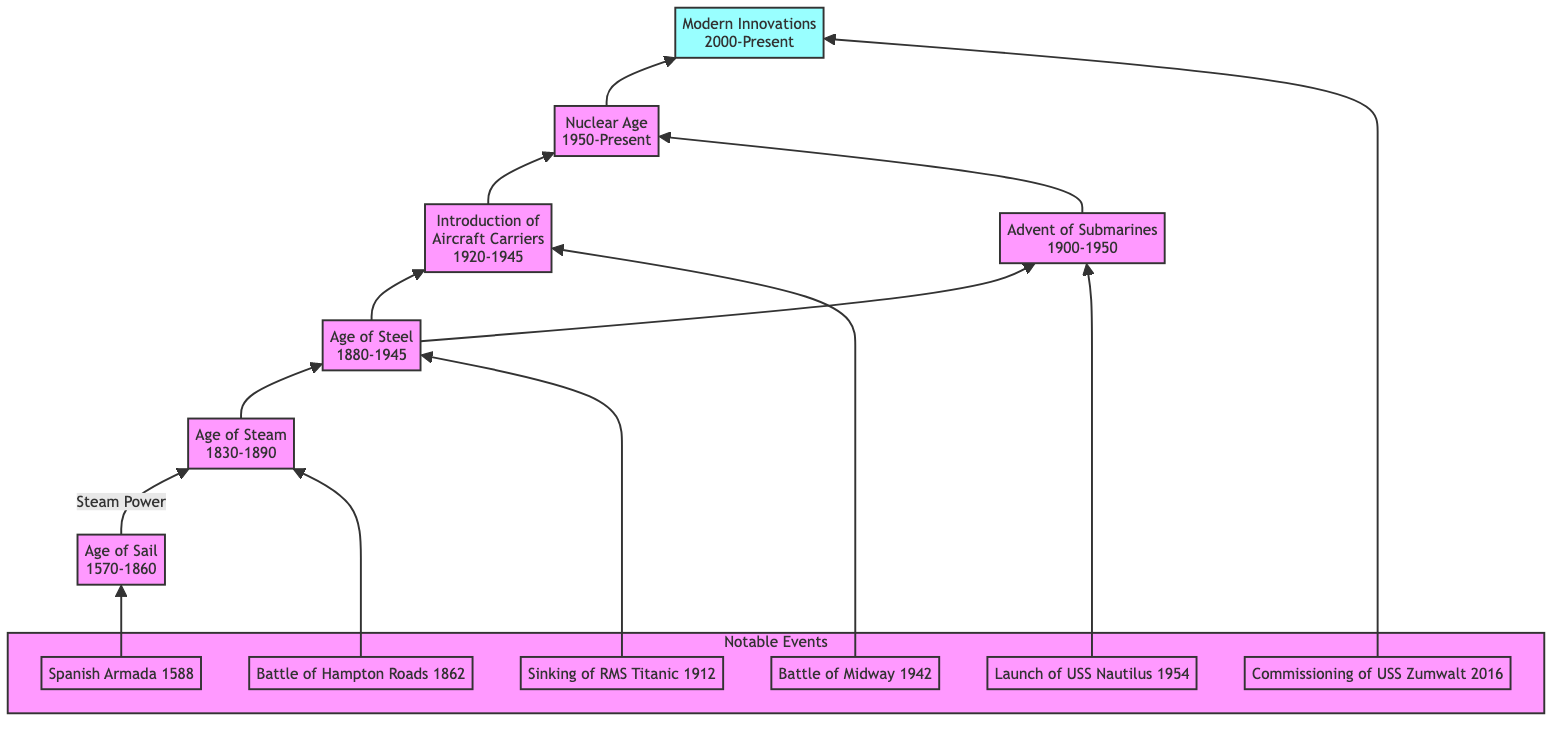What era introduced steam power in shipbuilding? The diagram shows that the Age of Steam (1830-1890) follows the Age of Sail (1570-1860) and is specifically marked by the introduction of steam power.
Answer: Age of Steam Which significant event corresponds to the Age of Steel? The diagram connects notable events to their respective eras. The sinking of the RMS Titanic in 1912 is linked to the Age of Steel (1880-1945).
Answer: Sinking of RMS Titanic Name a notable event associated with the introduction of aircraft carriers. The diagram lists notable events beneath the Introduction of Aircraft Carriers (1920-1945) node, specifically noting the Battle of Midway in 1942.
Answer: Battle of Midway How many major age categories are present in this shipbuilding progression? By counting the labeled age categories in the diagram—Age of Sail, Age of Steam, Age of Steel, Introduction of Aircraft Carriers, Advent of Submarines, Nuclear Age, and Modern Innovations—we find there are seven.
Answer: Seven Which ship type was introduced in the Nuclear Age? Looking at the Nuclear Age (1950-Present) in the diagram, it indicates the advancement to nuclear-powered ships, highlighting the USS Enterprise as a notable example.
Answer: Nuclear-powered ships Which two ages lead directly to the nuclear age? The diagram illustrates connections from the Age of Steel and the Advent of Submarines leading to the Nuclear Age, indicating they are both predecessors of this era.
Answer: Age of Steel and Advent of Submarines What is the latest innovation marked in the modern innovations era? The modern innovations era includes advancements such as the commissioning of the USS Zumwalt in 2016, which is indicated as a notable event in that section of the diagram.
Answer: Commissioning of USS Zumwalt How many edges connect the Age of Steel to subsequent naval developments? Within the diagram, the Age of Steel connects to three subsequent developments: Introduction of Aircraft Carriers, Advent of Submarines, and the Nuclear Age, creating three outgoing edges from that node.
Answer: Three What denotes the transition from wooden ships to nuclear submarines? The progression displayed in the diagram, which moves from the Age of Sail, through various ages, ultimately leading to the Nuclear Age and modern innovations, illustrates the complete transition.
Answer: Progression through the ages 